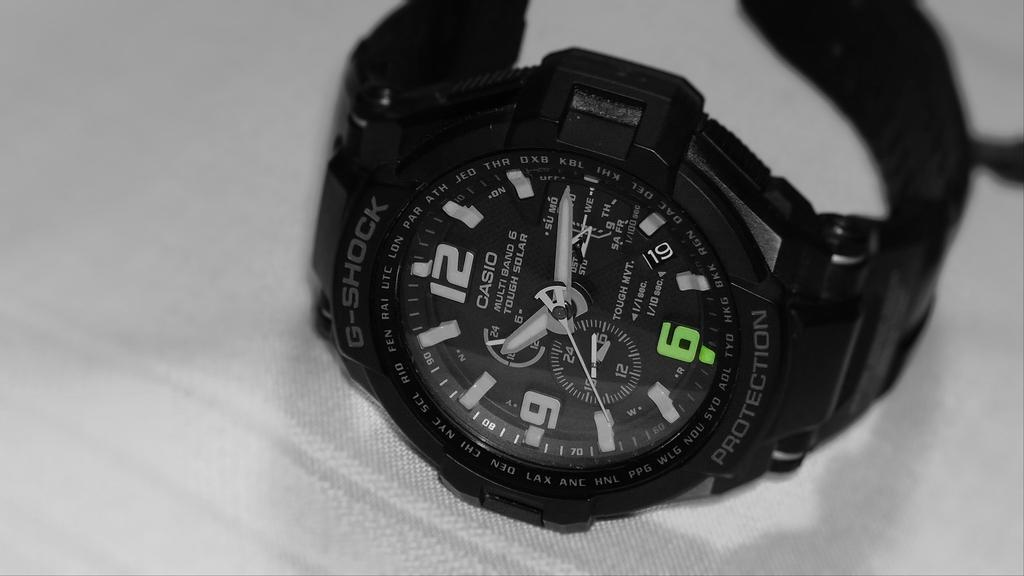<image>
Offer a succinct explanation of the picture presented. A Casio G-Shock watch sits on its side 